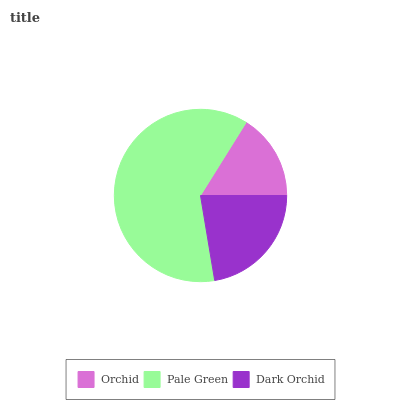Is Orchid the minimum?
Answer yes or no. Yes. Is Pale Green the maximum?
Answer yes or no. Yes. Is Dark Orchid the minimum?
Answer yes or no. No. Is Dark Orchid the maximum?
Answer yes or no. No. Is Pale Green greater than Dark Orchid?
Answer yes or no. Yes. Is Dark Orchid less than Pale Green?
Answer yes or no. Yes. Is Dark Orchid greater than Pale Green?
Answer yes or no. No. Is Pale Green less than Dark Orchid?
Answer yes or no. No. Is Dark Orchid the high median?
Answer yes or no. Yes. Is Dark Orchid the low median?
Answer yes or no. Yes. Is Orchid the high median?
Answer yes or no. No. Is Pale Green the low median?
Answer yes or no. No. 